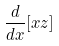<formula> <loc_0><loc_0><loc_500><loc_500>\frac { d } { d x } [ x z ]</formula> 